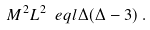<formula> <loc_0><loc_0><loc_500><loc_500>M ^ { 2 } L ^ { 2 } \ e q l \Delta ( \Delta - 3 ) \, .</formula> 